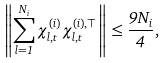Convert formula to latex. <formula><loc_0><loc_0><loc_500><loc_500>\left \| \sum _ { l = 1 } ^ { N _ { i } } \chi ^ { ( i ) } _ { l , t } \chi ^ { ( i ) , \top } _ { l , t } \right \| \leq \frac { 9 N _ { i } } { 4 } ,</formula> 